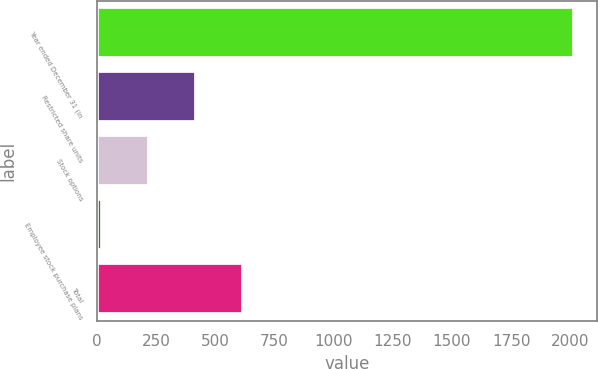Convert chart. <chart><loc_0><loc_0><loc_500><loc_500><bar_chart><fcel>Year ended December 31 (in<fcel>Restricted share units<fcel>Stock options<fcel>Employee stock purchase plans<fcel>Total<nl><fcel>2013<fcel>418.6<fcel>219.3<fcel>20<fcel>617.9<nl></chart> 